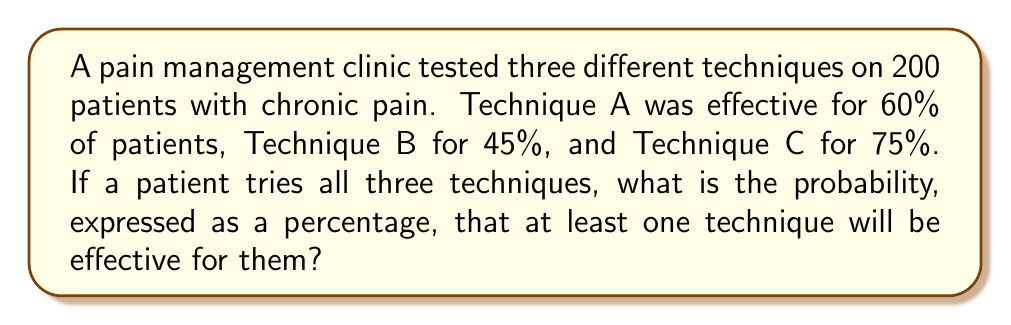Can you answer this question? Let's approach this step-by-step:

1) First, we need to find the probability that none of the techniques work. We can do this by calculating the probability of each technique not working and multiplying these probabilities together.

2) Probability of Technique A not working: $1 - 0.60 = 0.40$ or $40\%$
   Probability of Technique B not working: $1 - 0.45 = 0.55$ or $55\%$
   Probability of Technique C not working: $1 - 0.75 = 0.25$ or $25\%$

3) Probability that all techniques fail:
   $0.40 \times 0.55 \times 0.25 = 0.055$ or $5.5\%$

4) Therefore, the probability that at least one technique works is the opposite of all techniques failing:
   $1 - 0.055 = 0.945$ or $94.5\%$

5) Converting to a percentage:
   $0.945 \times 100\% = 94.5\%$
Answer: $94.5\%$ 